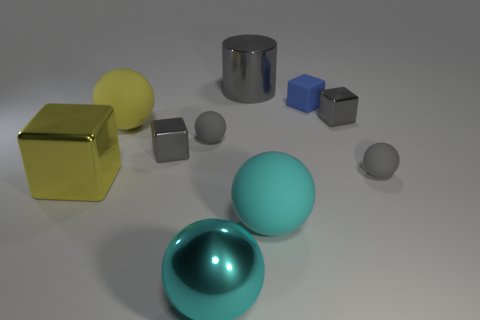Do the blue cube that is on the right side of the big gray metallic object and the metallic object that is left of the yellow ball have the same size? No, they do not have the same size. The blue cube on the right side of the big gray metallic cylinder is smaller than the cylinder itself. If we compare the blue cube to the metallic object located to the left of the yellow ball, which appears to be a smaller gray cube, it's evident that the blue cube is larger than the smaller gray cube. 